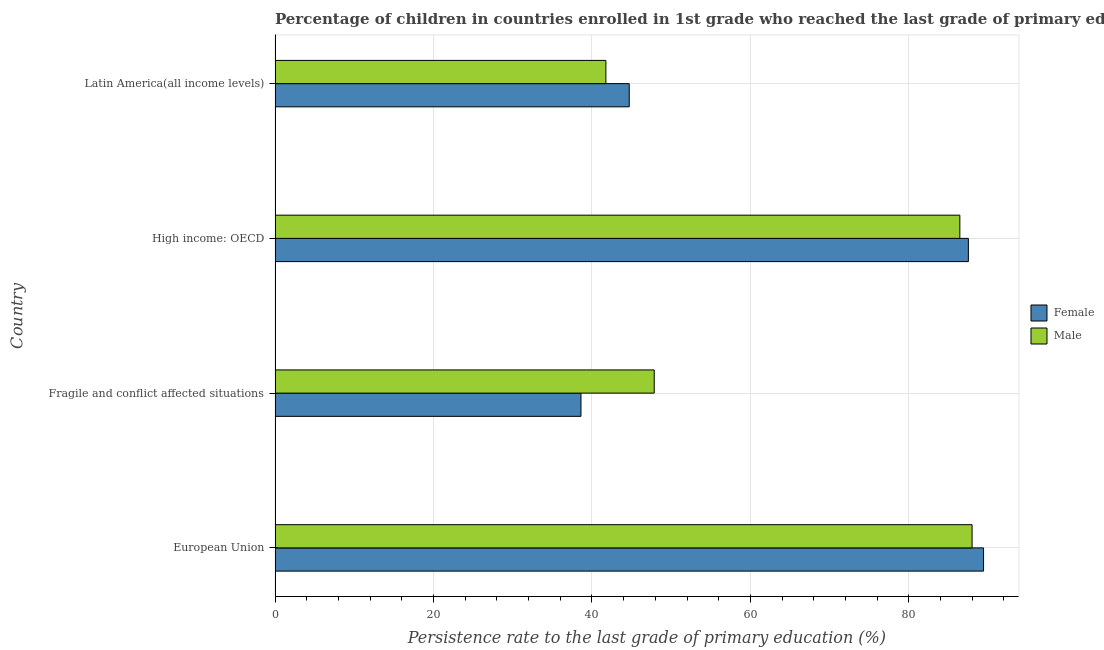How many different coloured bars are there?
Provide a short and direct response. 2. How many groups of bars are there?
Make the answer very short. 4. Are the number of bars per tick equal to the number of legend labels?
Offer a very short reply. Yes. Are the number of bars on each tick of the Y-axis equal?
Offer a very short reply. Yes. What is the label of the 4th group of bars from the top?
Give a very brief answer. European Union. What is the persistence rate of female students in High income: OECD?
Your answer should be compact. 87.52. Across all countries, what is the maximum persistence rate of male students?
Provide a short and direct response. 87.98. Across all countries, what is the minimum persistence rate of female students?
Offer a very short reply. 38.61. In which country was the persistence rate of male students minimum?
Your response must be concise. Latin America(all income levels). What is the total persistence rate of female students in the graph?
Offer a very short reply. 260.27. What is the difference between the persistence rate of female students in European Union and that in Fragile and conflict affected situations?
Your answer should be very brief. 50.82. What is the difference between the persistence rate of female students in Fragile and conflict affected situations and the persistence rate of male students in European Union?
Give a very brief answer. -49.37. What is the average persistence rate of male students per country?
Keep it short and to the point. 66.01. What is the difference between the persistence rate of female students and persistence rate of male students in Latin America(all income levels)?
Provide a short and direct response. 2.95. What is the ratio of the persistence rate of female students in European Union to that in Fragile and conflict affected situations?
Offer a very short reply. 2.32. Is the persistence rate of male students in European Union less than that in High income: OECD?
Your answer should be very brief. No. Is the difference between the persistence rate of male students in Fragile and conflict affected situations and High income: OECD greater than the difference between the persistence rate of female students in Fragile and conflict affected situations and High income: OECD?
Ensure brevity in your answer.  Yes. What is the difference between the highest and the second highest persistence rate of male students?
Offer a terse response. 1.54. What is the difference between the highest and the lowest persistence rate of female students?
Keep it short and to the point. 50.82. In how many countries, is the persistence rate of female students greater than the average persistence rate of female students taken over all countries?
Your answer should be compact. 2. What does the 1st bar from the top in Latin America(all income levels) represents?
Offer a very short reply. Male. What does the 1st bar from the bottom in Fragile and conflict affected situations represents?
Your answer should be very brief. Female. Are all the bars in the graph horizontal?
Give a very brief answer. Yes. How many countries are there in the graph?
Ensure brevity in your answer.  4. What is the difference between two consecutive major ticks on the X-axis?
Offer a terse response. 20. Are the values on the major ticks of X-axis written in scientific E-notation?
Your answer should be compact. No. Does the graph contain grids?
Ensure brevity in your answer.  Yes. Where does the legend appear in the graph?
Your response must be concise. Center right. What is the title of the graph?
Provide a succinct answer. Percentage of children in countries enrolled in 1st grade who reached the last grade of primary education. What is the label or title of the X-axis?
Provide a short and direct response. Persistence rate to the last grade of primary education (%). What is the Persistence rate to the last grade of primary education (%) of Female in European Union?
Offer a terse response. 89.43. What is the Persistence rate to the last grade of primary education (%) of Male in European Union?
Your response must be concise. 87.98. What is the Persistence rate to the last grade of primary education (%) of Female in Fragile and conflict affected situations?
Provide a succinct answer. 38.61. What is the Persistence rate to the last grade of primary education (%) in Male in Fragile and conflict affected situations?
Offer a very short reply. 47.86. What is the Persistence rate to the last grade of primary education (%) of Female in High income: OECD?
Your answer should be compact. 87.52. What is the Persistence rate to the last grade of primary education (%) in Male in High income: OECD?
Make the answer very short. 86.44. What is the Persistence rate to the last grade of primary education (%) in Female in Latin America(all income levels)?
Your answer should be very brief. 44.71. What is the Persistence rate to the last grade of primary education (%) of Male in Latin America(all income levels)?
Make the answer very short. 41.76. Across all countries, what is the maximum Persistence rate to the last grade of primary education (%) of Female?
Offer a very short reply. 89.43. Across all countries, what is the maximum Persistence rate to the last grade of primary education (%) in Male?
Your response must be concise. 87.98. Across all countries, what is the minimum Persistence rate to the last grade of primary education (%) in Female?
Give a very brief answer. 38.61. Across all countries, what is the minimum Persistence rate to the last grade of primary education (%) in Male?
Your response must be concise. 41.76. What is the total Persistence rate to the last grade of primary education (%) of Female in the graph?
Offer a very short reply. 260.27. What is the total Persistence rate to the last grade of primary education (%) of Male in the graph?
Ensure brevity in your answer.  264.04. What is the difference between the Persistence rate to the last grade of primary education (%) in Female in European Union and that in Fragile and conflict affected situations?
Your answer should be very brief. 50.82. What is the difference between the Persistence rate to the last grade of primary education (%) in Male in European Union and that in Fragile and conflict affected situations?
Keep it short and to the point. 40.12. What is the difference between the Persistence rate to the last grade of primary education (%) of Female in European Union and that in High income: OECD?
Make the answer very short. 1.92. What is the difference between the Persistence rate to the last grade of primary education (%) of Male in European Union and that in High income: OECD?
Keep it short and to the point. 1.54. What is the difference between the Persistence rate to the last grade of primary education (%) of Female in European Union and that in Latin America(all income levels)?
Ensure brevity in your answer.  44.73. What is the difference between the Persistence rate to the last grade of primary education (%) in Male in European Union and that in Latin America(all income levels)?
Your answer should be compact. 46.22. What is the difference between the Persistence rate to the last grade of primary education (%) in Female in Fragile and conflict affected situations and that in High income: OECD?
Offer a terse response. -48.9. What is the difference between the Persistence rate to the last grade of primary education (%) of Male in Fragile and conflict affected situations and that in High income: OECD?
Make the answer very short. -38.58. What is the difference between the Persistence rate to the last grade of primary education (%) of Female in Fragile and conflict affected situations and that in Latin America(all income levels)?
Your response must be concise. -6.09. What is the difference between the Persistence rate to the last grade of primary education (%) in Male in Fragile and conflict affected situations and that in Latin America(all income levels)?
Offer a very short reply. 6.1. What is the difference between the Persistence rate to the last grade of primary education (%) in Female in High income: OECD and that in Latin America(all income levels)?
Your answer should be very brief. 42.81. What is the difference between the Persistence rate to the last grade of primary education (%) of Male in High income: OECD and that in Latin America(all income levels)?
Make the answer very short. 44.68. What is the difference between the Persistence rate to the last grade of primary education (%) in Female in European Union and the Persistence rate to the last grade of primary education (%) in Male in Fragile and conflict affected situations?
Keep it short and to the point. 41.57. What is the difference between the Persistence rate to the last grade of primary education (%) in Female in European Union and the Persistence rate to the last grade of primary education (%) in Male in High income: OECD?
Your answer should be compact. 2.99. What is the difference between the Persistence rate to the last grade of primary education (%) in Female in European Union and the Persistence rate to the last grade of primary education (%) in Male in Latin America(all income levels)?
Offer a very short reply. 47.67. What is the difference between the Persistence rate to the last grade of primary education (%) in Female in Fragile and conflict affected situations and the Persistence rate to the last grade of primary education (%) in Male in High income: OECD?
Your response must be concise. -47.83. What is the difference between the Persistence rate to the last grade of primary education (%) in Female in Fragile and conflict affected situations and the Persistence rate to the last grade of primary education (%) in Male in Latin America(all income levels)?
Keep it short and to the point. -3.15. What is the difference between the Persistence rate to the last grade of primary education (%) of Female in High income: OECD and the Persistence rate to the last grade of primary education (%) of Male in Latin America(all income levels)?
Offer a very short reply. 45.76. What is the average Persistence rate to the last grade of primary education (%) in Female per country?
Give a very brief answer. 65.07. What is the average Persistence rate to the last grade of primary education (%) in Male per country?
Keep it short and to the point. 66.01. What is the difference between the Persistence rate to the last grade of primary education (%) in Female and Persistence rate to the last grade of primary education (%) in Male in European Union?
Your answer should be compact. 1.45. What is the difference between the Persistence rate to the last grade of primary education (%) in Female and Persistence rate to the last grade of primary education (%) in Male in Fragile and conflict affected situations?
Give a very brief answer. -9.25. What is the difference between the Persistence rate to the last grade of primary education (%) in Female and Persistence rate to the last grade of primary education (%) in Male in High income: OECD?
Your answer should be very brief. 1.08. What is the difference between the Persistence rate to the last grade of primary education (%) in Female and Persistence rate to the last grade of primary education (%) in Male in Latin America(all income levels)?
Provide a short and direct response. 2.95. What is the ratio of the Persistence rate to the last grade of primary education (%) in Female in European Union to that in Fragile and conflict affected situations?
Your answer should be compact. 2.32. What is the ratio of the Persistence rate to the last grade of primary education (%) in Male in European Union to that in Fragile and conflict affected situations?
Your answer should be very brief. 1.84. What is the ratio of the Persistence rate to the last grade of primary education (%) of Female in European Union to that in High income: OECD?
Offer a very short reply. 1.02. What is the ratio of the Persistence rate to the last grade of primary education (%) in Male in European Union to that in High income: OECD?
Ensure brevity in your answer.  1.02. What is the ratio of the Persistence rate to the last grade of primary education (%) of Female in European Union to that in Latin America(all income levels)?
Your answer should be very brief. 2. What is the ratio of the Persistence rate to the last grade of primary education (%) of Male in European Union to that in Latin America(all income levels)?
Provide a succinct answer. 2.11. What is the ratio of the Persistence rate to the last grade of primary education (%) of Female in Fragile and conflict affected situations to that in High income: OECD?
Offer a very short reply. 0.44. What is the ratio of the Persistence rate to the last grade of primary education (%) in Male in Fragile and conflict affected situations to that in High income: OECD?
Your answer should be compact. 0.55. What is the ratio of the Persistence rate to the last grade of primary education (%) of Female in Fragile and conflict affected situations to that in Latin America(all income levels)?
Your answer should be very brief. 0.86. What is the ratio of the Persistence rate to the last grade of primary education (%) of Male in Fragile and conflict affected situations to that in Latin America(all income levels)?
Give a very brief answer. 1.15. What is the ratio of the Persistence rate to the last grade of primary education (%) of Female in High income: OECD to that in Latin America(all income levels)?
Offer a very short reply. 1.96. What is the ratio of the Persistence rate to the last grade of primary education (%) in Male in High income: OECD to that in Latin America(all income levels)?
Ensure brevity in your answer.  2.07. What is the difference between the highest and the second highest Persistence rate to the last grade of primary education (%) of Female?
Offer a very short reply. 1.92. What is the difference between the highest and the second highest Persistence rate to the last grade of primary education (%) in Male?
Keep it short and to the point. 1.54. What is the difference between the highest and the lowest Persistence rate to the last grade of primary education (%) in Female?
Offer a very short reply. 50.82. What is the difference between the highest and the lowest Persistence rate to the last grade of primary education (%) in Male?
Offer a very short reply. 46.22. 